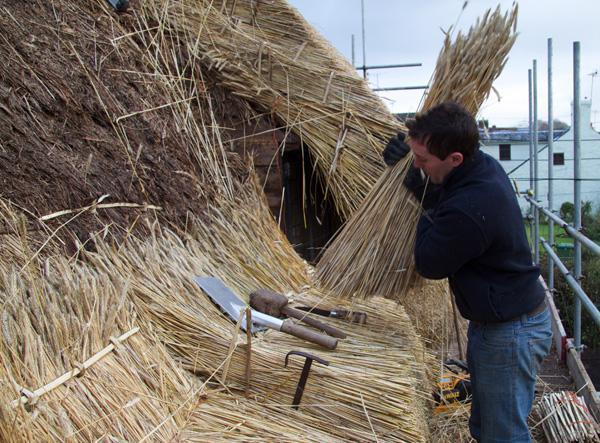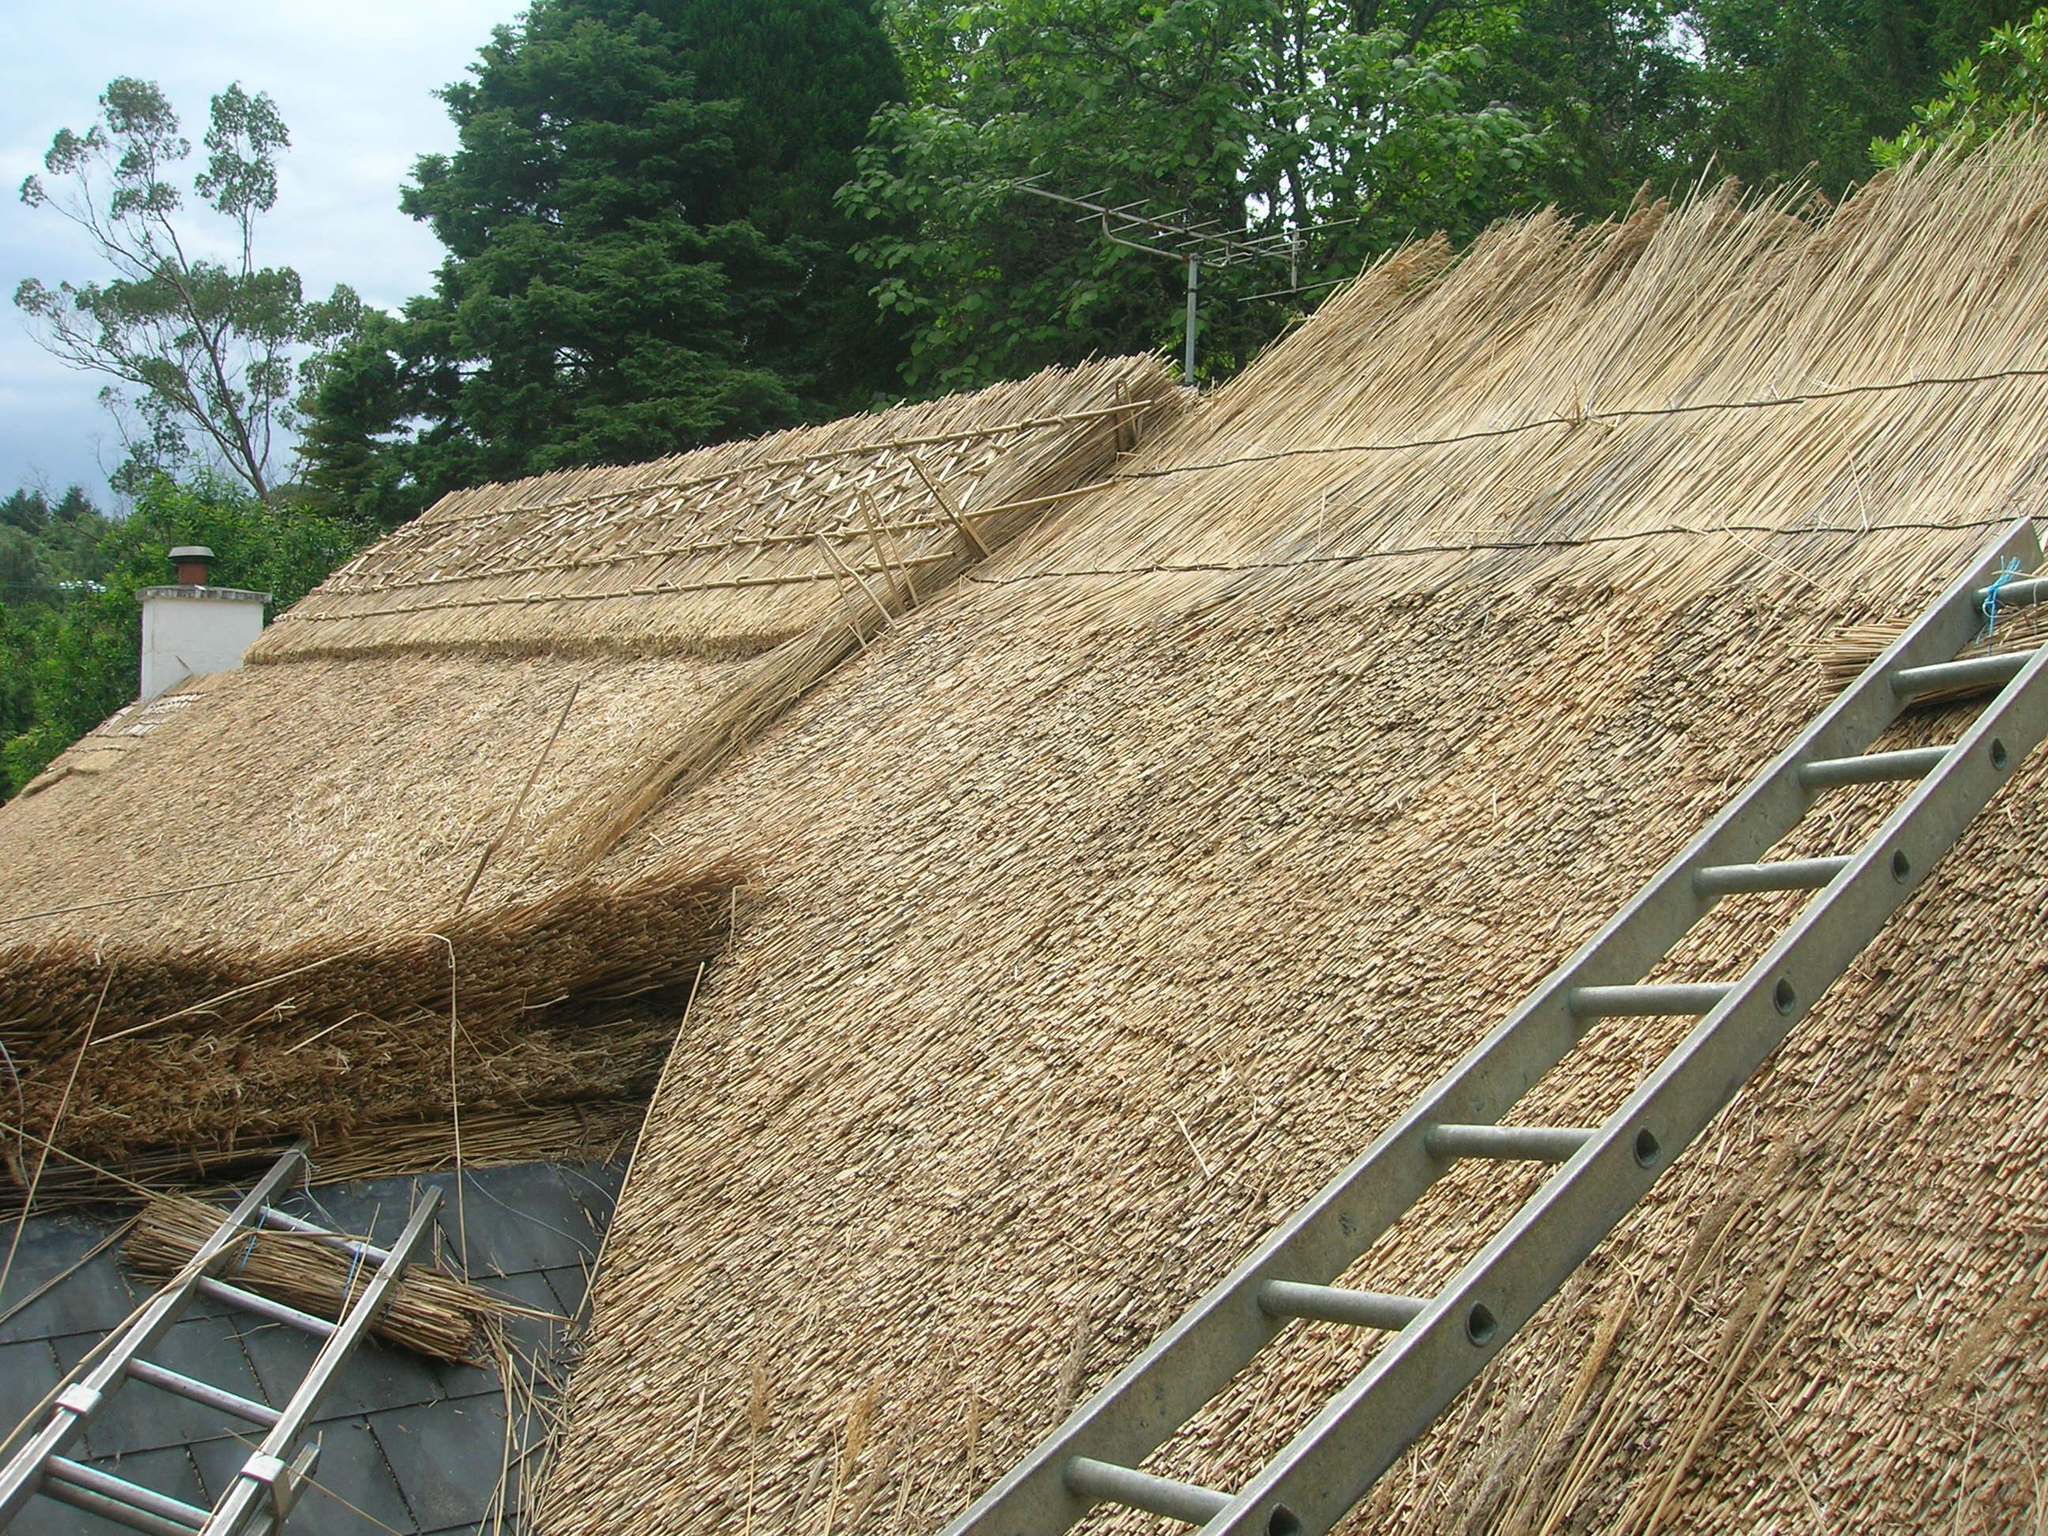The first image is the image on the left, the second image is the image on the right. Given the left and right images, does the statement "The left image shows a man installing a thatch roof, and the right image shows a ladder propped on an unfinished roof piled with thatch." hold true? Answer yes or no. Yes. The first image is the image on the left, the second image is the image on the right. Assess this claim about the two images: "There are windows in the right image.". Correct or not? Answer yes or no. No. 